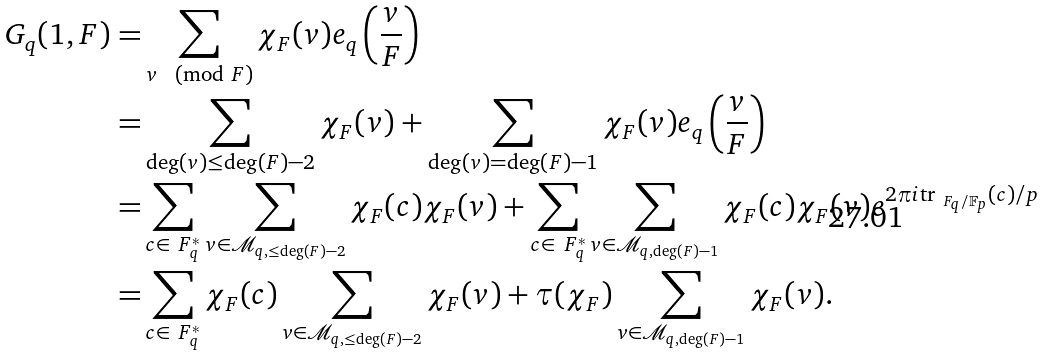Convert formula to latex. <formula><loc_0><loc_0><loc_500><loc_500>G _ { q } ( 1 , F ) = & \sum _ { v \pmod { F } } \chi _ { F } ( v ) e _ { q } \left ( \frac { v } { F } \right ) \\ = & \sum _ { \deg ( v ) \leq \deg ( F ) - 2 } \chi _ { F } ( v ) + \sum _ { \deg ( v ) = \deg ( F ) - 1 } \chi _ { F } ( v ) e _ { q } \left ( \frac { v } { F } \right ) \\ = & \sum _ { c \in \ F _ { q } ^ { * } } \sum _ { v \in \mathcal { M } _ { q , \leq \deg ( F ) - 2 } } \chi _ { F } ( c ) \chi _ { F } ( v ) + \sum _ { c \in \ F _ { q } ^ { * } } \sum _ { v \in \mathcal { M } _ { q , \deg ( F ) - 1 } } \chi _ { F } ( c ) \chi _ { F } ( v ) e ^ { 2 \pi i \text {tr} _ { \ F _ { q } / \mathbb { F } _ { p } } ( c ) / p } \\ = & \sum _ { c \in \ F _ { q } ^ { * } } \chi _ { F } ( c ) \sum _ { v \in \mathcal { M } _ { q , \leq \deg ( F ) - 2 } } \chi _ { F } ( v ) + \tau ( \chi _ { F } ) \sum _ { v \in \mathcal { M } _ { q , \deg ( F ) - 1 } } \chi _ { F } ( v ) . \\</formula> 